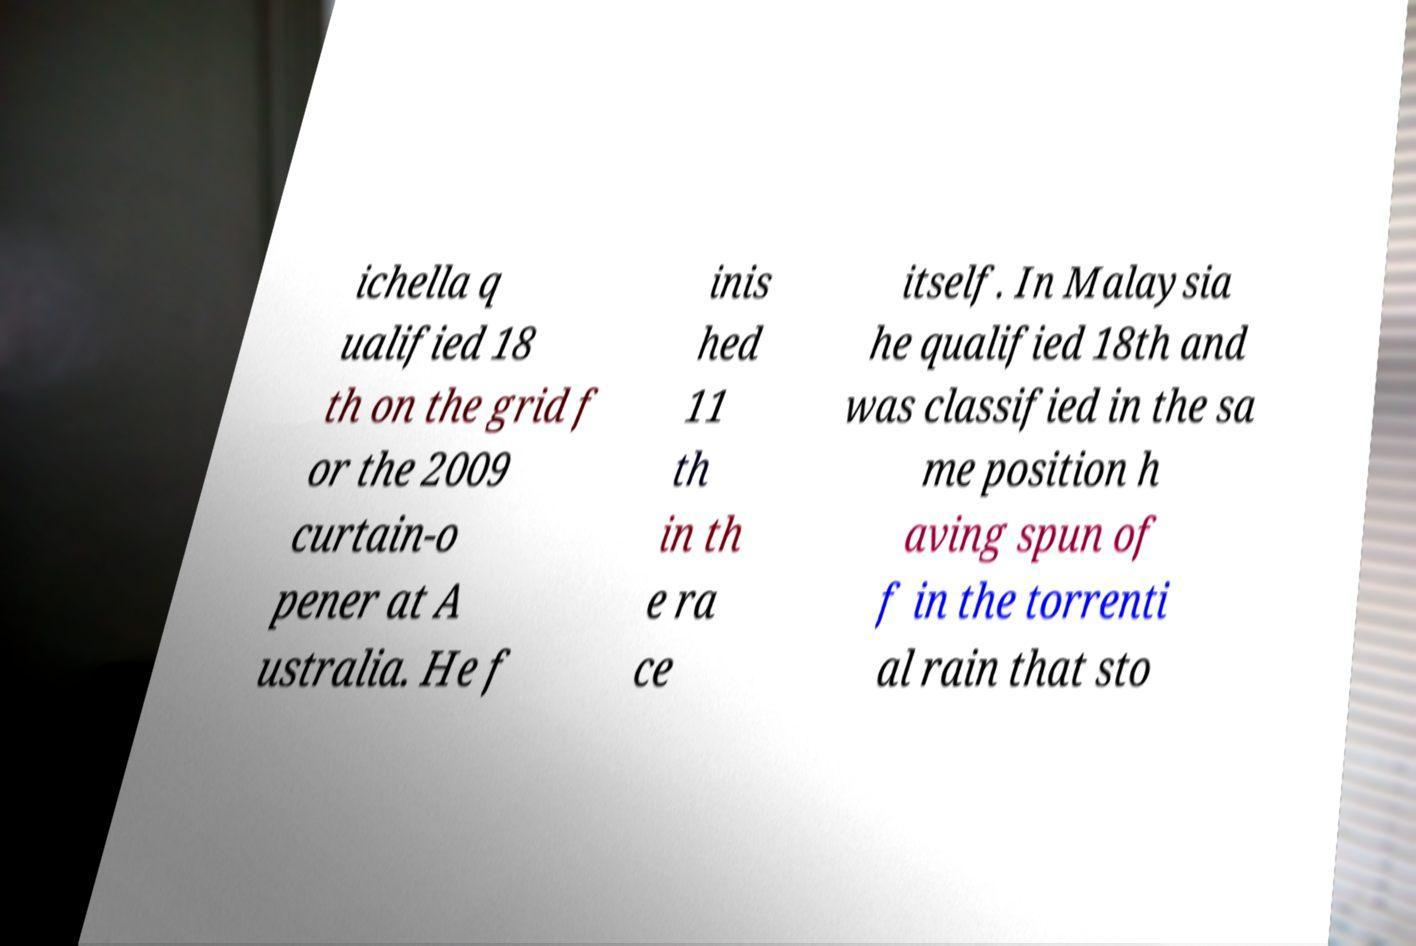Please read and relay the text visible in this image. What does it say? ichella q ualified 18 th on the grid f or the 2009 curtain-o pener at A ustralia. He f inis hed 11 th in th e ra ce itself. In Malaysia he qualified 18th and was classified in the sa me position h aving spun of f in the torrenti al rain that sto 